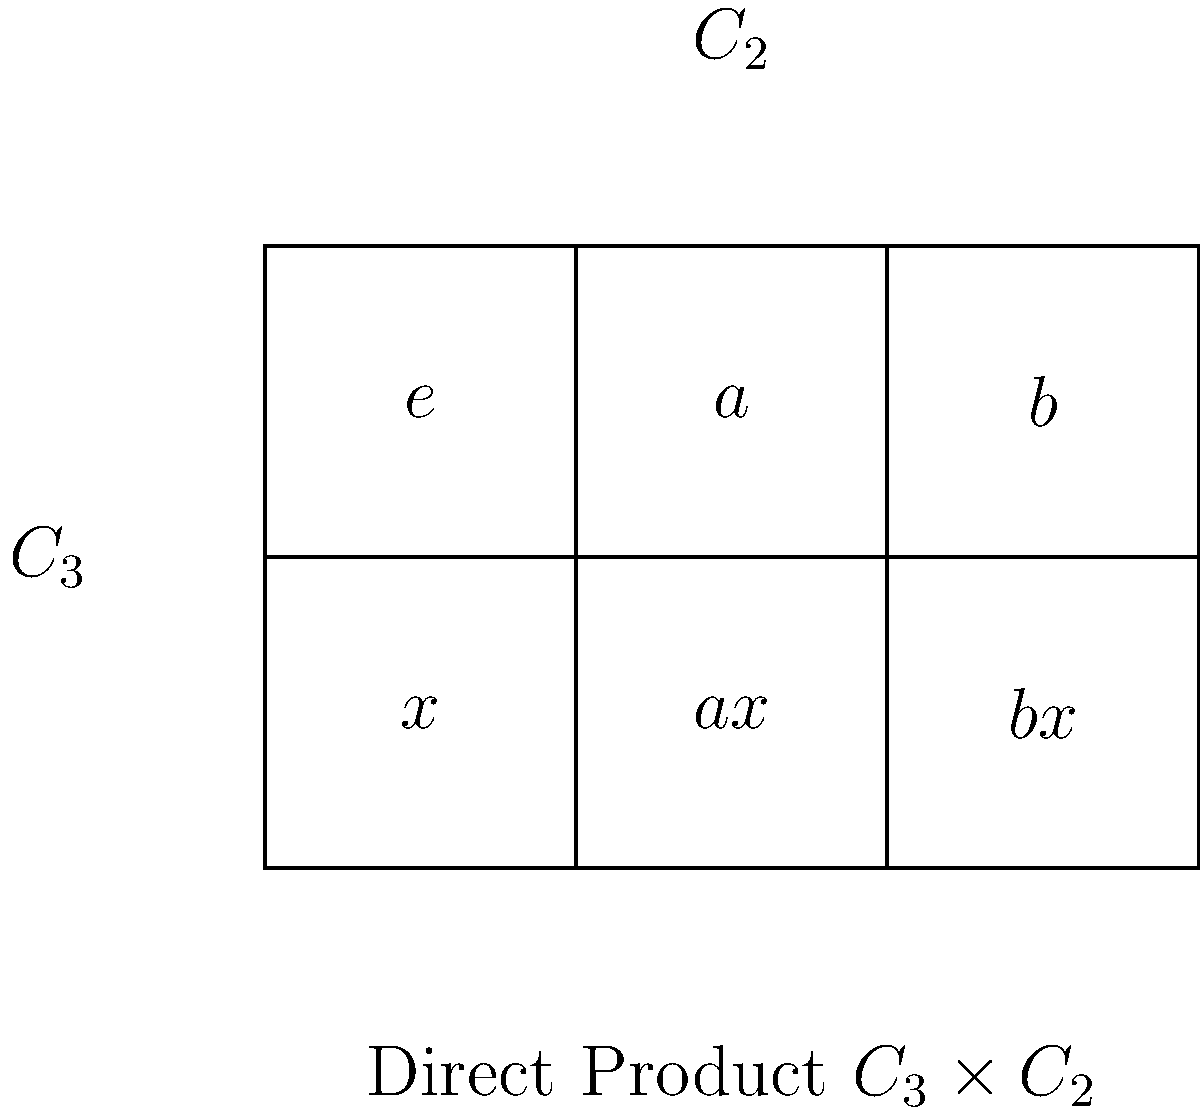As an investment banker accustomed to analyzing complex financial structures, consider the direct product of two cyclic groups $C_3 \times C_2$ represented in the grid above. If we define a homomorphism $\phi: C_3 \times C_2 \rightarrow G$ where $G$ is some group, and $\phi(a,x) = \phi(b,e)$, what is the order of the kernel of $\phi$? Let's approach this step-by-step:

1) First, recall that for a homomorphism $\phi$, the kernel is the set of all elements that map to the identity in the codomain.

2) We're given that $\phi(a,x) = \phi(b,e)$. This means $(a,x)(b,e)^{-1}$ is in the kernel of $\phi$.

3) In $C_3$, we have $b = a^2$, so $(b,e)^{-1} = (a^2,e)^{-1} = (a,e)$.

4) Therefore, $(a,x)(a,e)^{-1} = (e,x)$ is in the kernel.

5) Since $(e,x)$ is in the kernel, and $x$ generates $C_2$, we know that the entire subgroup $\{(e,e), (e,x)\}$ is in the kernel.

6) Moreover, since $\phi(a,x) = \phi(b,e)$, we can deduce that $\phi(a,e) = \phi(b,x)$.

7) This implies that $(a,e)(b,x)^{-1} = (a,e)(a,x) = (e,x)$ is also in the kernel.

8) Given these relations, we can conclude that the kernel contains all elements of $C_3 \times C_2$.

9) The order of $C_3 \times C_2$ is $|C_3| \times |C_2| = 3 \times 2 = 6$.

Therefore, the order of the kernel of $\phi$ is 6.
Answer: 6 